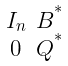Convert formula to latex. <formula><loc_0><loc_0><loc_500><loc_500>\begin{smallmatrix} I _ { n } & B ^ { ^ { * } } \\ 0 & Q ^ { ^ { * } } \end{smallmatrix}</formula> 